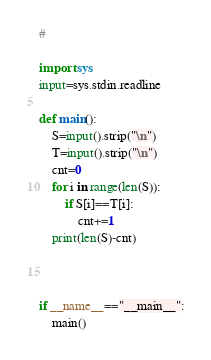<code> <loc_0><loc_0><loc_500><loc_500><_Python_>#

import sys
input=sys.stdin.readline

def main():
    S=input().strip("\n")
    T=input().strip("\n")
    cnt=0
    for i in range(len(S)):
        if S[i]==T[i]:
            cnt+=1
    print(len(S)-cnt)
    
    
    
if __name__=="__main__":
    main()
</code> 